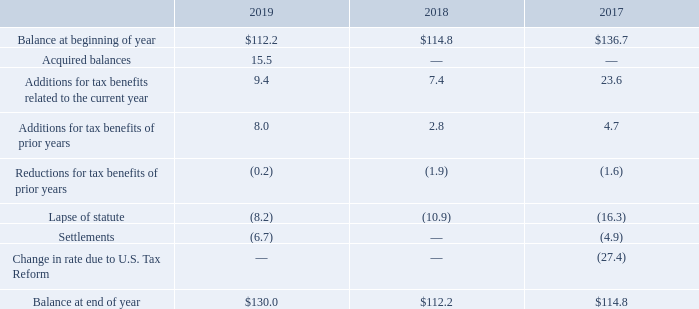The activity for unrecognized gross tax benefits is as follows (in millions):
Included in the December 31, 2019 balance of $130.0 million is $97.2 million related to unrecognized tax benefits that, if recognized, would impact the annual effective tax rate. Also included in the balance of unrecognized tax benefits as of December 31, 2019 is $32.8 million of benefit that, if recognized, would result in adjustments to other tax accounts, primarily deferred taxes.
Although the Company cannot predict the timing of resolution with taxing authorities, if any, the Company believes it is reasonably possible that its unrecognized tax benefits will be reduced by $1.5 million in the next 12 months due to settlement with tax authorities or expiration of the applicable statute of limitations. The Company did not recognize any additional tax benefit or expense for interest and penalties during the year ended December 31, 2019.
The Company recognized approximately $0.8 million of tax benefit and $1.5 million of tax expense for interest and penalties during the years ended December 31, 2018 and 2017, respectively. The Company had approximately $5.1 million, $5.1 million, and $5.9 million of accrued interest and penalties at December 31, 2019, 2018, and 2017, respectively. The Company recognizes interest and penalties accrued in relation to unrecognized tax benefits in tax expense.
Tax years prior to 2016 are generally not subject to examination by the IRS except for items involving tax attributes that have been carried forward to tax years whose statute of limitations remains open. The Company is not currently under IRS examination. For state returns, the Company is generally not subject to income tax examinations for years prior to 2015.
The Company is also subject to routine examinations by various foreign tax jurisdictions in which it operates. With respect to jurisdictions outside the United States, the Company's subsidiaries are generally no longer subject to income tax audits for years prior to 2009. The Company is currently under audit in the following jurisdictions including, but not limited to, Canada, China, the Czech Republic, the Philippines, Singapore and the United Kingdom.
How much was accrued interest and penalties at December 31, 2019? $5.1 million. How much was accrued interest and penalties at December 31, 2018? $5.1 million. How much was accrued interest and penalties at December 31, 2017? $5.9 million. What is the change in Additions for tax benefits related to the current year from December 31, 2018 to 2019?
Answer scale should be: million. 9.4-7.4
Answer: 2. What is the change in Lapse of statute from year ended December 31, 2018 to 2019?
Answer scale should be: million. -8.2-(10.9)
Answer: 2.7. What is the average Additions for tax benefits related to the current year for December 31, 2018 and 2019?
Answer scale should be: million. (9.4+7.4) / 2
Answer: 8.4. 